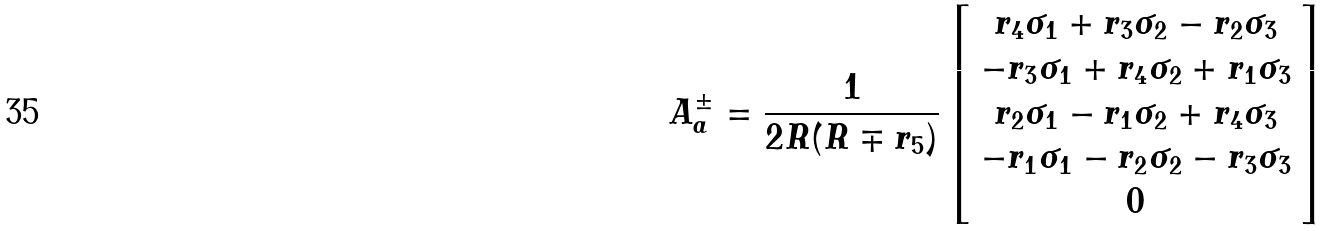Convert formula to latex. <formula><loc_0><loc_0><loc_500><loc_500>A _ { a } ^ { \pm } = \frac { 1 } { 2 R ( R \mp r _ { 5 } ) } \left [ \begin{array} { c } r _ { 4 } \sigma _ { 1 } + r _ { 3 } \sigma _ { 2 } - r _ { 2 } \sigma _ { 3 } \\ - r _ { 3 } \sigma _ { 1 } + r _ { 4 } \sigma _ { 2 } + r _ { 1 } \sigma _ { 3 } \\ r _ { 2 } \sigma _ { 1 } - r _ { 1 } \sigma _ { 2 } + r _ { 4 } \sigma _ { 3 } \\ - r _ { 1 } \sigma _ { 1 } - r _ { 2 } \sigma _ { 2 } - r _ { 3 } \sigma _ { 3 } \\ 0 \end{array} \right ]</formula> 